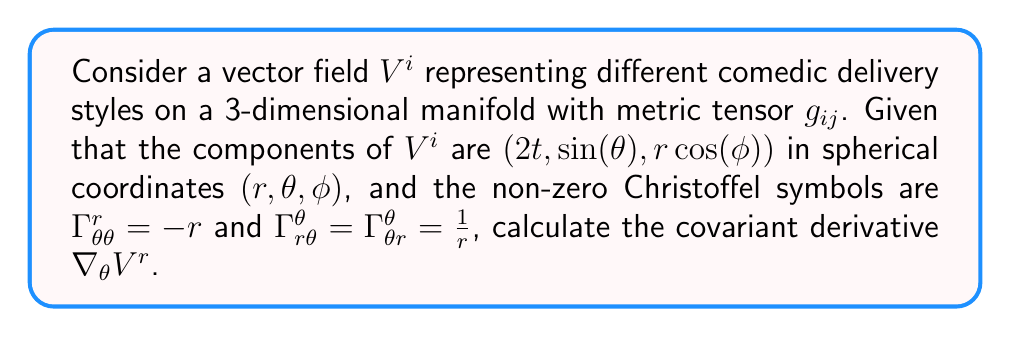What is the answer to this math problem? To calculate the covariant derivative $\nabla_\theta V^r$, we use the formula:

$$\nabla_\theta V^r = \partial_\theta V^r + \Gamma^r_{\theta i} V^i$$

Step 1: Calculate $\partial_\theta V^r$
$V^r = 2t$, which is independent of $\theta$, so $\partial_\theta V^r = 0$

Step 2: Expand $\Gamma^r_{\theta i} V^i$
$$\Gamma^r_{\theta i} V^i = \Gamma^r_{\theta r} V^r + \Gamma^r_{\theta \theta} V^\theta + \Gamma^r_{\theta \phi} V^\phi$$

Step 3: Substitute known values
- $\Gamma^r_{\theta \theta} = -r$
- $V^\theta = \sin(\theta)$
- Other Christoffel symbols are zero

$$\Gamma^r_{\theta i} V^i = 0 \cdot V^r + (-r) \cdot \sin(\theta) + 0 \cdot V^\phi = -r\sin(\theta)$$

Step 4: Combine results
$$\nabla_\theta V^r = \partial_\theta V^r + \Gamma^r_{\theta i} V^i = 0 + (-r\sin(\theta)) = -r\sin(\theta)$$
Answer: $-r\sin(\theta)$ 